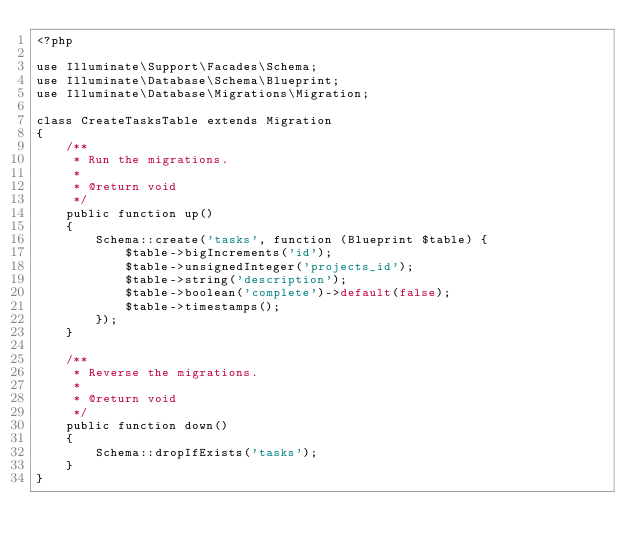Convert code to text. <code><loc_0><loc_0><loc_500><loc_500><_PHP_><?php

use Illuminate\Support\Facades\Schema;
use Illuminate\Database\Schema\Blueprint;
use Illuminate\Database\Migrations\Migration;

class CreateTasksTable extends Migration
{
    /**
     * Run the migrations.
     *
     * @return void
     */
    public function up()
    {
        Schema::create('tasks', function (Blueprint $table) {
            $table->bigIncrements('id');
            $table->unsignedInteger('projects_id');
            $table->string('description');
            $table->boolean('complete')->default(false);
            $table->timestamps();
        });
    }

    /**
     * Reverse the migrations.
     *
     * @return void
     */
    public function down()
    {
        Schema::dropIfExists('tasks');
    }
}
</code> 